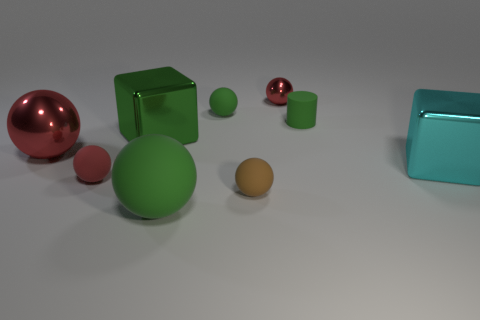Subtract all yellow blocks. How many red spheres are left? 3 Subtract 2 spheres. How many spheres are left? 4 Subtract all green balls. How many balls are left? 4 Subtract all large matte balls. How many balls are left? 5 Subtract all brown spheres. Subtract all green cubes. How many spheres are left? 5 Subtract all blocks. How many objects are left? 7 Subtract 0 purple cylinders. How many objects are left? 9 Subtract all cylinders. Subtract all metal spheres. How many objects are left? 6 Add 7 large metallic balls. How many large metallic balls are left? 8 Add 8 tiny metallic balls. How many tiny metallic balls exist? 9 